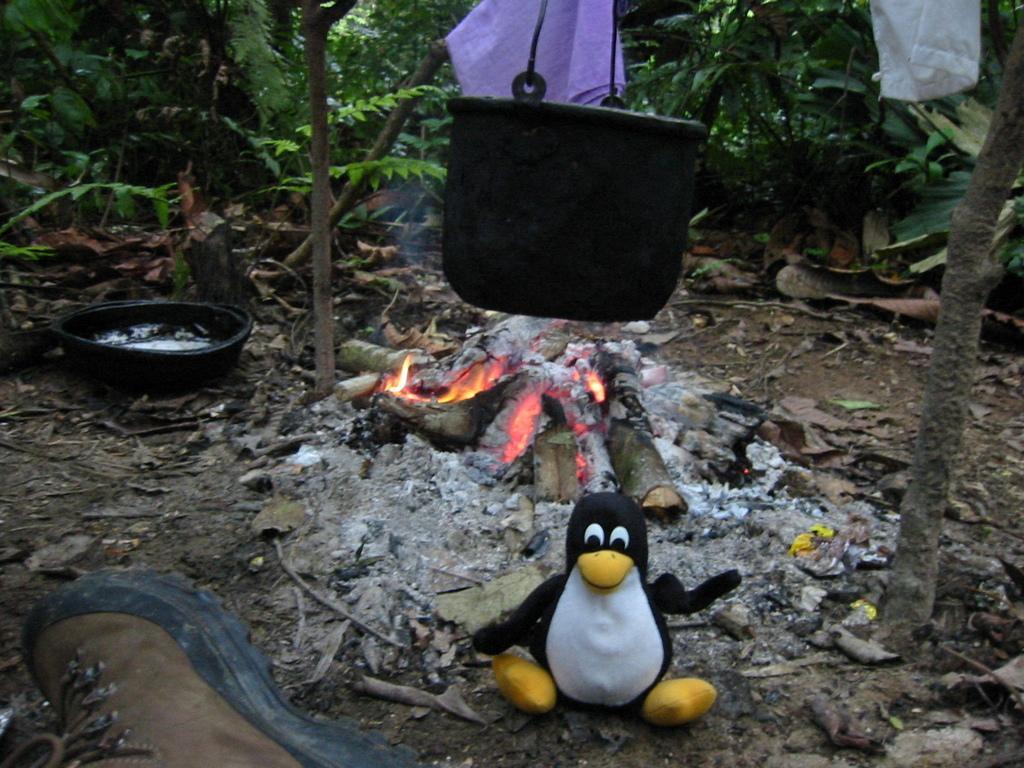How would you summarize this image in a sentence or two? In this image, we can see a black color container hanging and there is fire on the ground, we can see a toy and there are some clothes hanging, we can see some trees. 